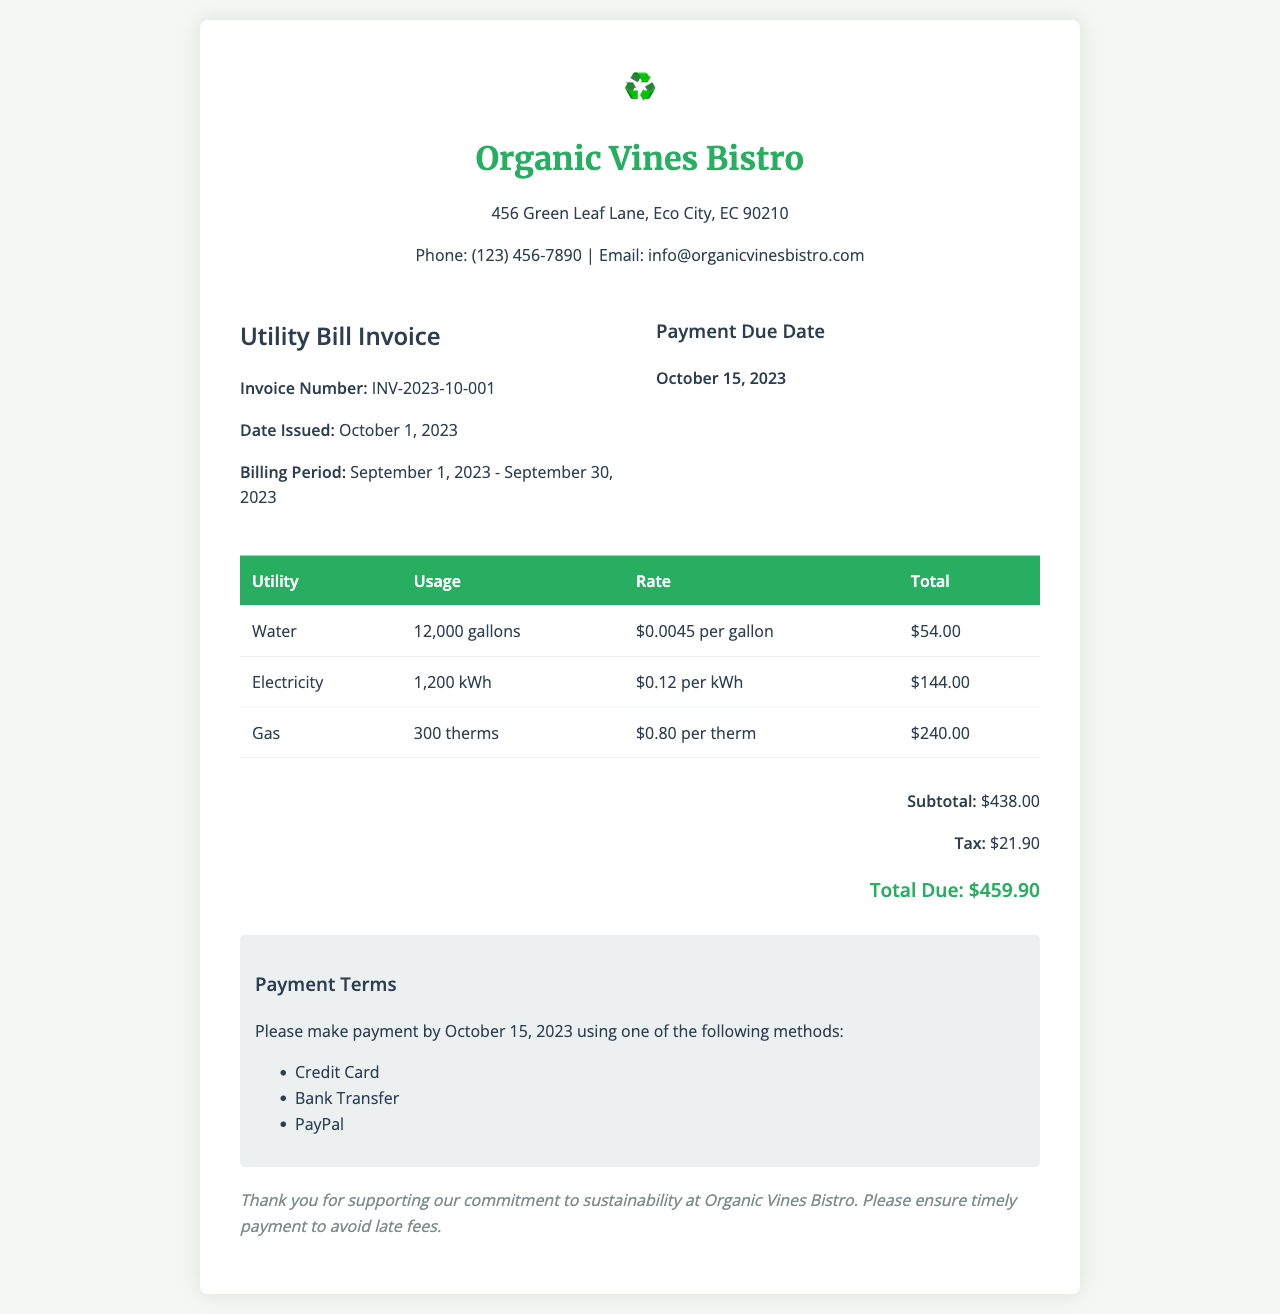What is the invoice number? The invoice number is listed in the document to uniquely identify this bill, which is INV-2023-10-001.
Answer: INV-2023-10-001 What is the total due amount? The total due is calculated by adding the subtotal and tax, which is $438.00 + $21.90 = $459.90.
Answer: $459.90 What is the billing period? The billing period refers to the dates for which the utility services were used, which is from September 1, 2023 to September 30, 2023.
Answer: September 1, 2023 - September 30, 2023 How much was charged for gas? The total charge for gas is provided in the breakdown table of the invoice, which is $240.00.
Answer: $240.00 What is the payment due date? The payment due date indicates when the payment should be made to avoid late fees, which is October 15, 2023.
Answer: October 15, 2023 How many kilowatt-hours were used? The usage of electricity is specified in the document, listed as the number of kilowatts consumed, which is 1,200 kWh.
Answer: 1,200 kWh What is the tax amount? The tax amount is detailed in the total section of the invoice, which is $21.90.
Answer: $21.90 What is the rate for water usage? The rate applied for water is clearly stated in the utility breakdown, which is $0.0045 per gallon.
Answer: $0.0045 per gallon What methods of payment are accepted? Different payment methods are presented, which include Credit Card, Bank Transfer, and PayPal.
Answer: Credit Card, Bank Transfer, PayPal 